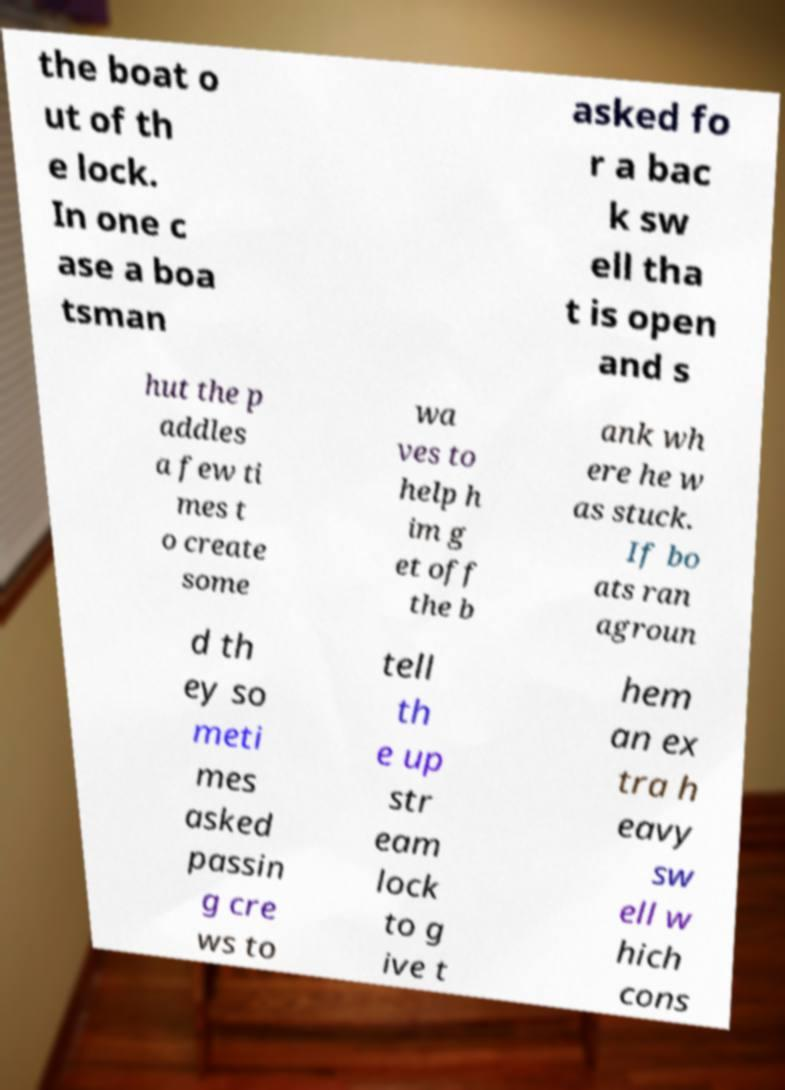Please read and relay the text visible in this image. What does it say? the boat o ut of th e lock. In one c ase a boa tsman asked fo r a bac k sw ell tha t is open and s hut the p addles a few ti mes t o create some wa ves to help h im g et off the b ank wh ere he w as stuck. If bo ats ran agroun d th ey so meti mes asked passin g cre ws to tell th e up str eam lock to g ive t hem an ex tra h eavy sw ell w hich cons 